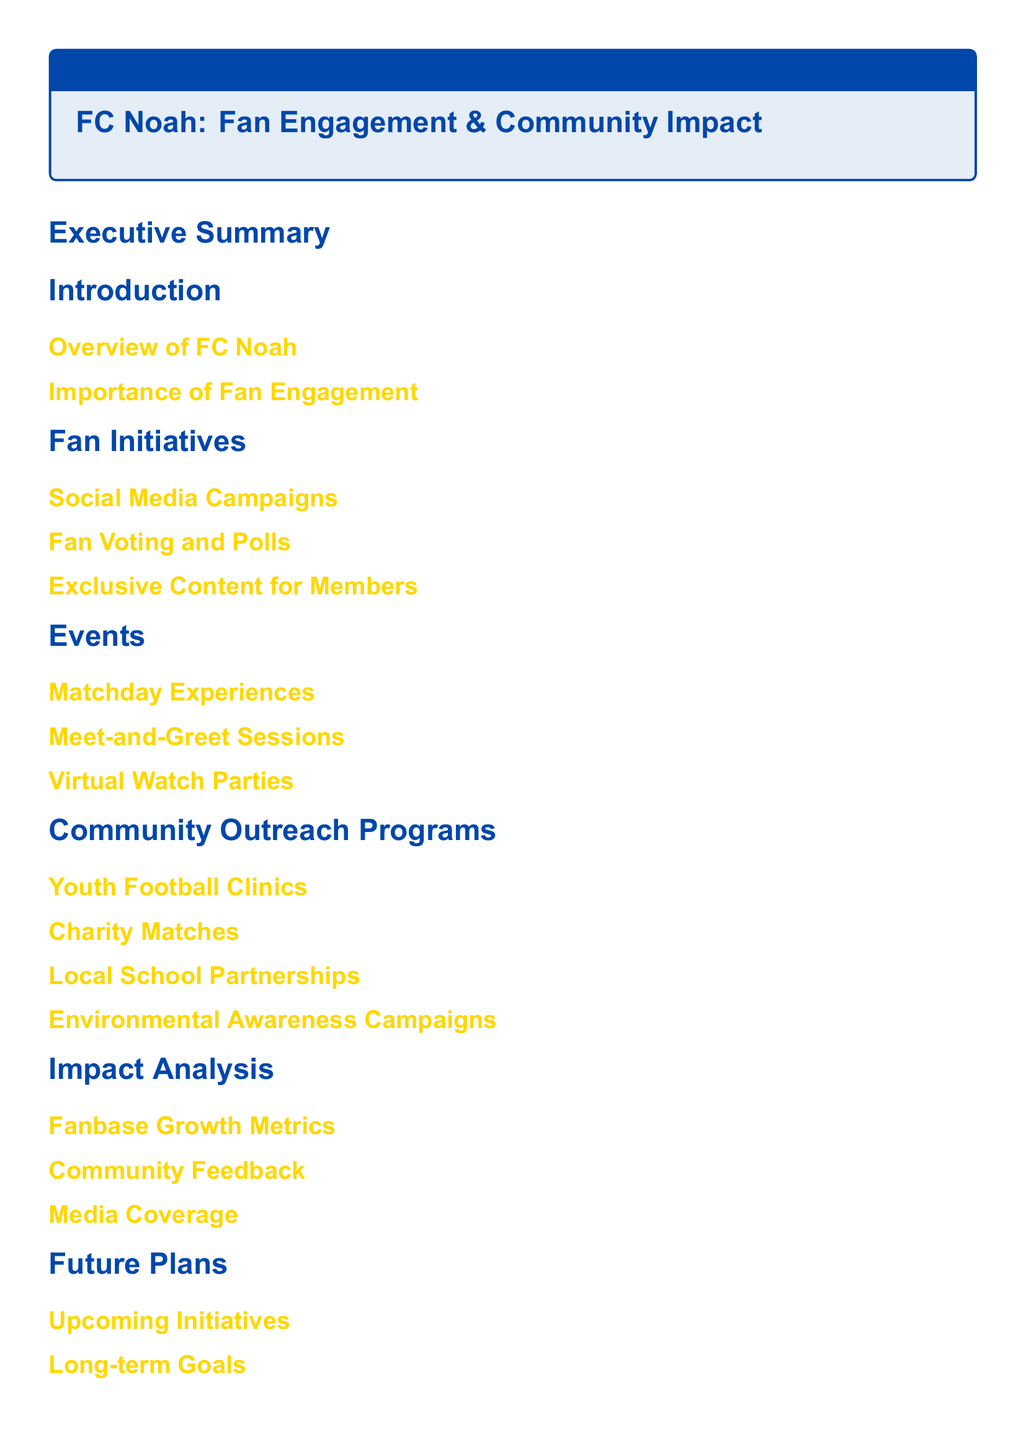What is the title of the report? The title is presented in the header of the Table of Contents section.
Answer: FC Noah: Fan Engagement & Community Impact How many main sections are there in the document? The number of main sections can be counted from the Table of Contents.
Answer: 7 What is the first subsection under "Fan Initiatives"? The subsections can be listed based on their order in the document.
Answer: Social Media Campaigns Which section discusses "Environmental Awareness Campaigns"? The section names are indicated in the Table of Contents.
Answer: Community Outreach Programs What type of events does FC Noah organize to engage fans? The types of events can be inferred from the "Events" section title.
Answer: Matchday Experiences What is the purpose of the "Charity Matches" program? The purpose is implied under the Community Outreach Programs section, focusing on community impact.
Answer: Community Outreach What are the two focuses of the "Future Plans" section? The titles in the "Future Plans" subsection provide insights into their goals.
Answer: Upcoming Initiatives, Long-term Goals Which section contains information on "Fanbase Growth Metrics"? The section titles guide where specific metrics are discussed.
Answer: Impact Analysis 